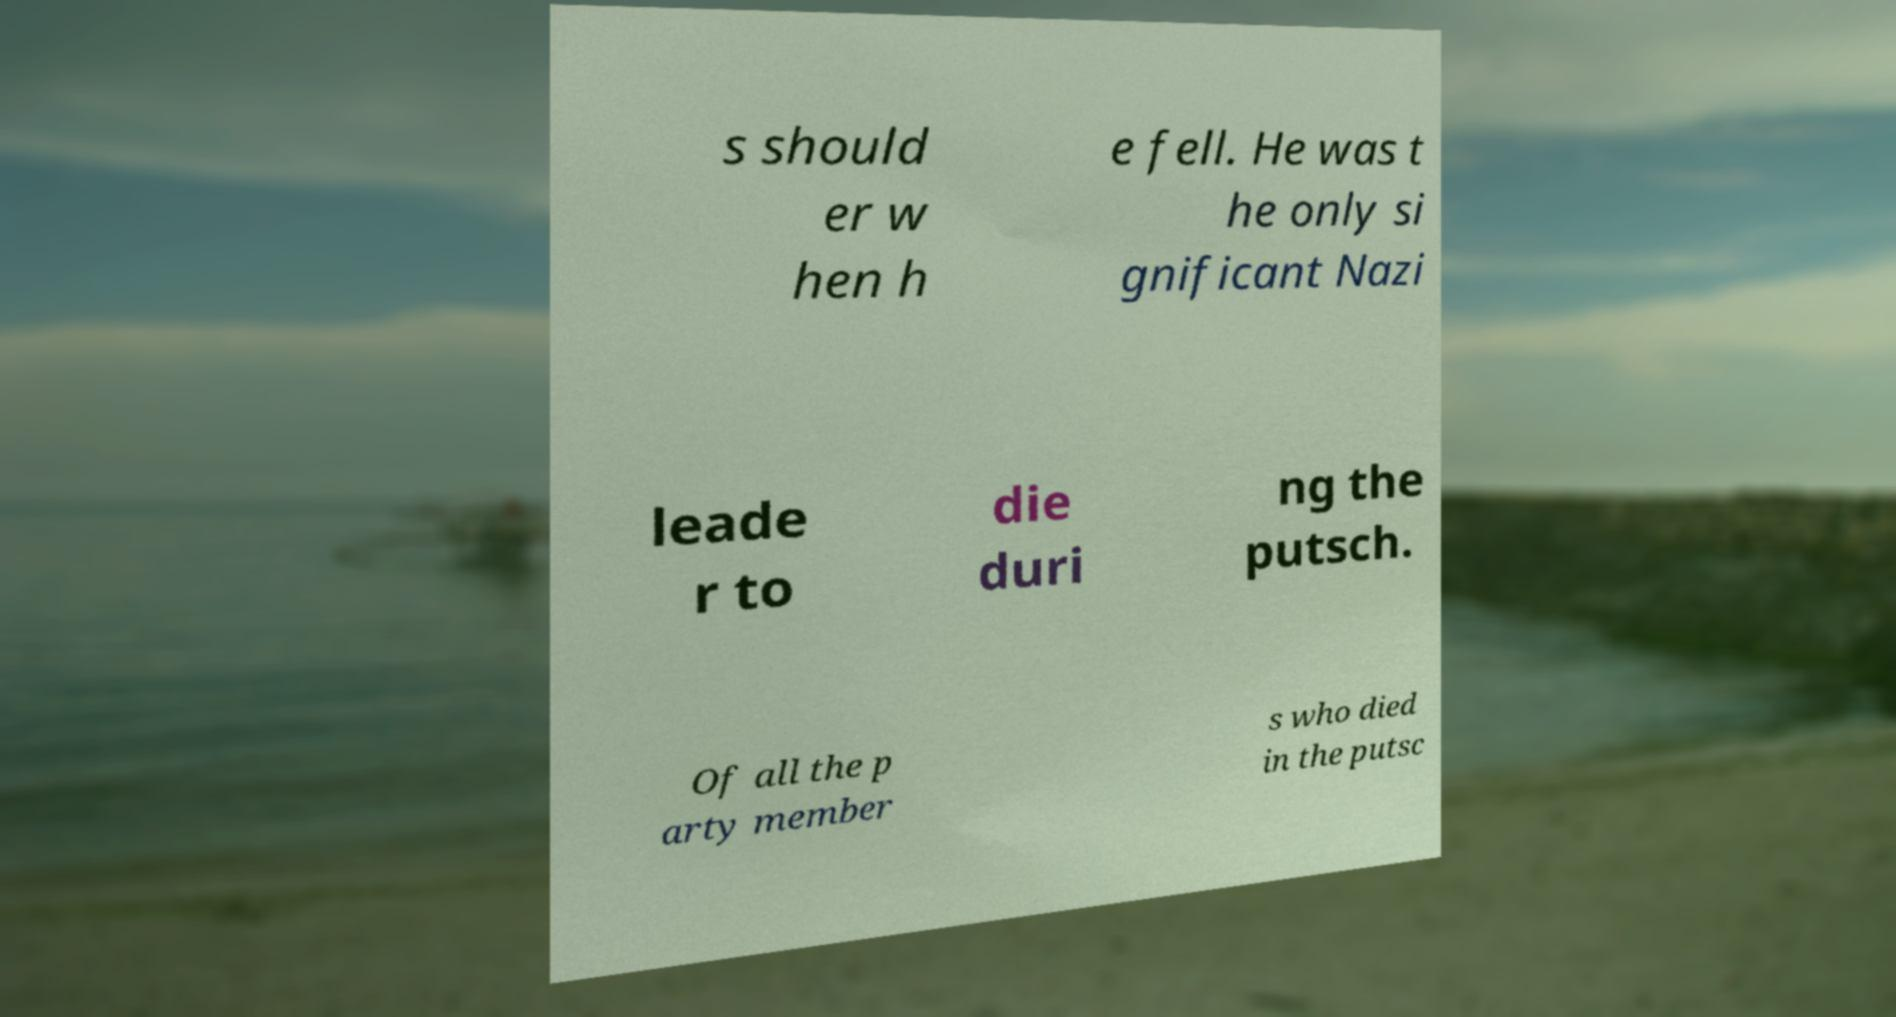Could you extract and type out the text from this image? s should er w hen h e fell. He was t he only si gnificant Nazi leade r to die duri ng the putsch. Of all the p arty member s who died in the putsc 